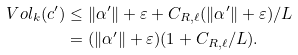Convert formula to latex. <formula><loc_0><loc_0><loc_500><loc_500>\ V o l _ { k } ( c ^ { \prime } ) & \leq \| \alpha ^ { \prime } \| + \varepsilon + C _ { R , \ell } ( \| \alpha ^ { \prime } \| + \varepsilon ) / L \\ & = ( \| \alpha ^ { \prime } \| + \varepsilon ) ( 1 + C _ { R , \ell } / L ) .</formula> 